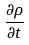<formula> <loc_0><loc_0><loc_500><loc_500>\frac { \partial \rho } { \partial t }</formula> 